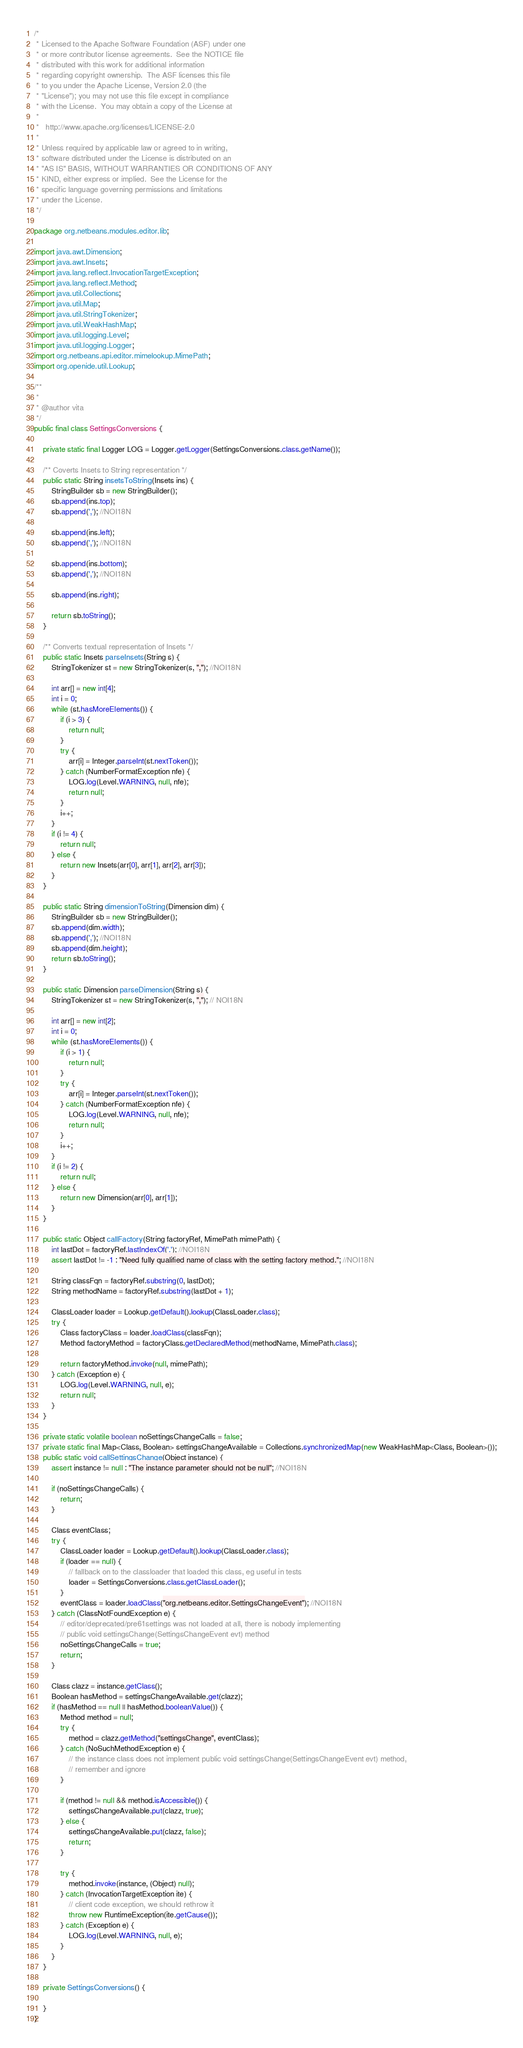Convert code to text. <code><loc_0><loc_0><loc_500><loc_500><_Java_>/*
 * Licensed to the Apache Software Foundation (ASF) under one
 * or more contributor license agreements.  See the NOTICE file
 * distributed with this work for additional information
 * regarding copyright ownership.  The ASF licenses this file
 * to you under the Apache License, Version 2.0 (the
 * "License"); you may not use this file except in compliance
 * with the License.  You may obtain a copy of the License at
 *
 *   http://www.apache.org/licenses/LICENSE-2.0
 *
 * Unless required by applicable law or agreed to in writing,
 * software distributed under the License is distributed on an
 * "AS IS" BASIS, WITHOUT WARRANTIES OR CONDITIONS OF ANY
 * KIND, either express or implied.  See the License for the
 * specific language governing permissions and limitations
 * under the License.
 */

package org.netbeans.modules.editor.lib;

import java.awt.Dimension;
import java.awt.Insets;
import java.lang.reflect.InvocationTargetException;
import java.lang.reflect.Method;
import java.util.Collections;
import java.util.Map;
import java.util.StringTokenizer;
import java.util.WeakHashMap;
import java.util.logging.Level;
import java.util.logging.Logger;
import org.netbeans.api.editor.mimelookup.MimePath;
import org.openide.util.Lookup;

/**
 *
 * @author vita
 */
public final class SettingsConversions {

    private static final Logger LOG = Logger.getLogger(SettingsConversions.class.getName());
    
    /** Coverts Insets to String representation */
    public static String insetsToString(Insets ins) {
        StringBuilder sb = new StringBuilder();
        sb.append(ins.top);
        sb.append(','); //NOI18N

        sb.append(ins.left);
        sb.append(','); //NOI18N

        sb.append(ins.bottom);
        sb.append(','); //NOI18N

        sb.append(ins.right);

        return sb.toString();
    }

    /** Converts textual representation of Insets */
    public static Insets parseInsets(String s) {
        StringTokenizer st = new StringTokenizer(s, ","); //NOI18N

        int arr[] = new int[4];
        int i = 0;
        while (st.hasMoreElements()) {
            if (i > 3) {
                return null;
            }
            try {
                arr[i] = Integer.parseInt(st.nextToken());
            } catch (NumberFormatException nfe) {
                LOG.log(Level.WARNING, null, nfe);
                return null;
            }
            i++;
        }
        if (i != 4) {
            return null;
        } else {
            return new Insets(arr[0], arr[1], arr[2], arr[3]);
        }
    }
    
    public static String dimensionToString(Dimension dim) {
        StringBuilder sb = new StringBuilder();
        sb.append(dim.width);
        sb.append(','); //NOI18N
        sb.append(dim.height);
        return sb.toString();
    }

    public static Dimension parseDimension(String s) {
        StringTokenizer st = new StringTokenizer(s, ","); // NOI18N

        int arr[] = new int[2];
        int i = 0;
        while (st.hasMoreElements()) {
            if (i > 1) {
                return null;
            }
            try {
                arr[i] = Integer.parseInt(st.nextToken());
            } catch (NumberFormatException nfe) {
                LOG.log(Level.WARNING, null, nfe);
                return null;
            }
            i++;
        }
        if (i != 2) {
            return null;
        } else {
            return new Dimension(arr[0], arr[1]);
        }
    }

    public static Object callFactory(String factoryRef, MimePath mimePath) {
        int lastDot = factoryRef.lastIndexOf('.'); //NOI18N
        assert lastDot != -1 : "Need fully qualified name of class with the setting factory method."; //NOI18N

        String classFqn = factoryRef.substring(0, lastDot);
        String methodName = factoryRef.substring(lastDot + 1);

        ClassLoader loader = Lookup.getDefault().lookup(ClassLoader.class);
        try {
            Class factoryClass = loader.loadClass(classFqn);
            Method factoryMethod = factoryClass.getDeclaredMethod(methodName, MimePath.class);

            return factoryMethod.invoke(null, mimePath);
        } catch (Exception e) {
            LOG.log(Level.WARNING, null, e);
            return null;
        }
    }

    private static volatile boolean noSettingsChangeCalls = false;
    private static final Map<Class, Boolean> settingsChangeAvailable = Collections.synchronizedMap(new WeakHashMap<Class, Boolean>());
    public static void callSettingsChange(Object instance) {
        assert instance != null : "The instance parameter should not be null"; //NOI18N
        
        if (noSettingsChangeCalls) {
            return;
        }
        
        Class eventClass;
        try {
            ClassLoader loader = Lookup.getDefault().lookup(ClassLoader.class);
            if (loader == null) {
                // fallback on to the classloader that loaded this class, eg useful in tests
                loader = SettingsConversions.class.getClassLoader();
            }
            eventClass = loader.loadClass("org.netbeans.editor.SettingsChangeEvent"); //NOI18N
        } catch (ClassNotFoundException e) {
            // editor/deprecated/pre61settings was not loaded at all, there is nobody implementing
            // public void settingsChange(SettingsChangeEvent evt) method
            noSettingsChangeCalls = true;
            return;
        }

        Class clazz = instance.getClass();
        Boolean hasMethod = settingsChangeAvailable.get(clazz);
        if (hasMethod == null || hasMethod.booleanValue()) {
            Method method = null;
            try {
                method = clazz.getMethod("settingsChange", eventClass);
            } catch (NoSuchMethodException e) {
                // the instance class does not implement public void settingsChange(SettingsChangeEvent evt) method,
                // remember and ignore
            }

            if (method != null && method.isAccessible()) {
                settingsChangeAvailable.put(clazz, true);
            } else {
                settingsChangeAvailable.put(clazz, false);
                return;
            }
            
            try {
                method.invoke(instance, (Object) null);
            } catch (InvocationTargetException ite) {
                // client code exception, we should rethrow it
                throw new RuntimeException(ite.getCause());
            } catch (Exception e) {
                LOG.log(Level.WARNING, null, e);
            }
        }
    }
    
    private SettingsConversions() {
        
    }
}
</code> 